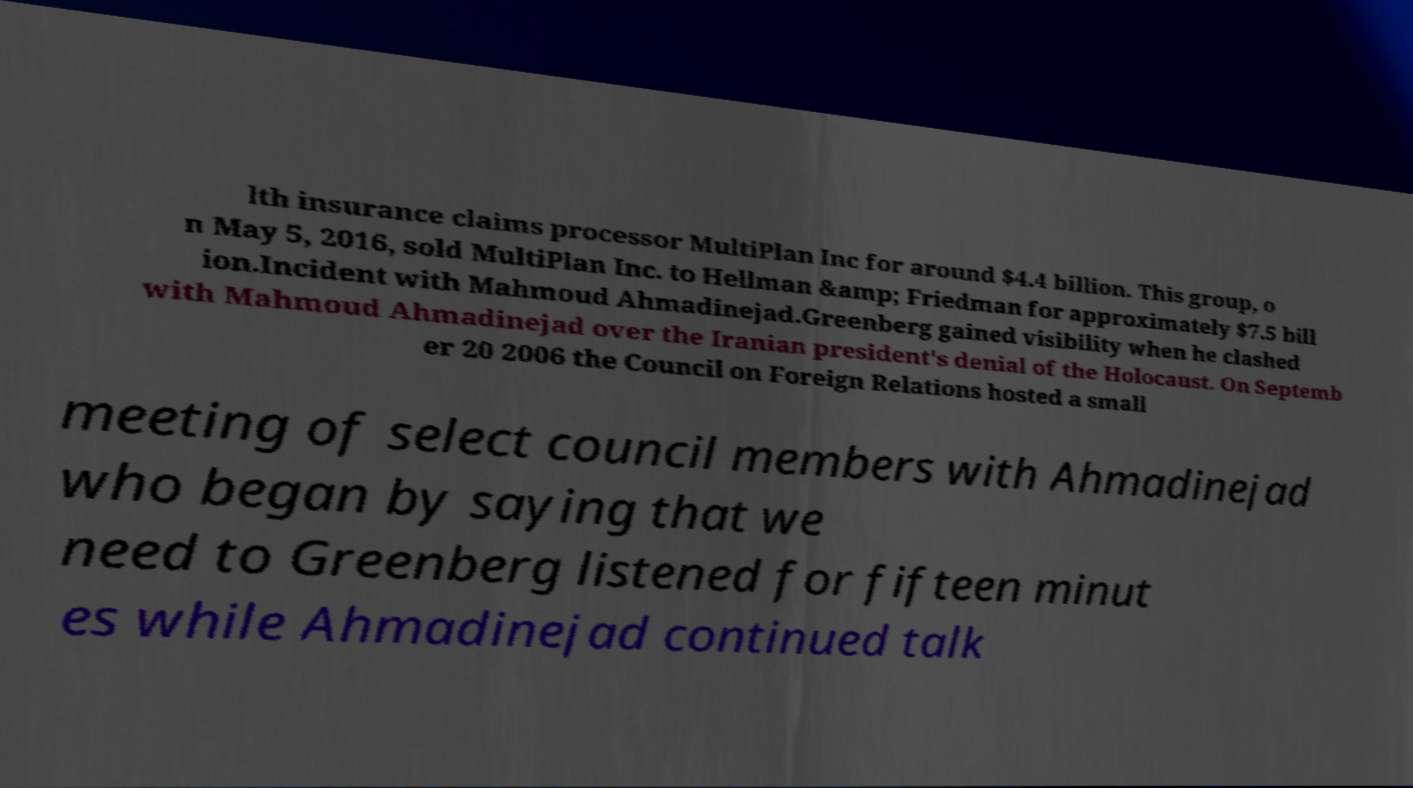Could you assist in decoding the text presented in this image and type it out clearly? lth insurance claims processor MultiPlan Inc for around $4.4 billion. This group, o n May 5, 2016, sold MultiPlan Inc. to Hellman &amp; Friedman for approximately $7.5 bill ion.Incident with Mahmoud Ahmadinejad.Greenberg gained visibility when he clashed with Mahmoud Ahmadinejad over the Iranian president's denial of the Holocaust. On Septemb er 20 2006 the Council on Foreign Relations hosted a small meeting of select council members with Ahmadinejad who began by saying that we need to Greenberg listened for fifteen minut es while Ahmadinejad continued talk 